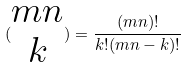Convert formula to latex. <formula><loc_0><loc_0><loc_500><loc_500>( \begin{matrix} m n \\ k \end{matrix} ) = \frac { ( m n ) ! } { k ! ( m n - k ) ! }</formula> 